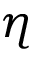Convert formula to latex. <formula><loc_0><loc_0><loc_500><loc_500>\eta</formula> 